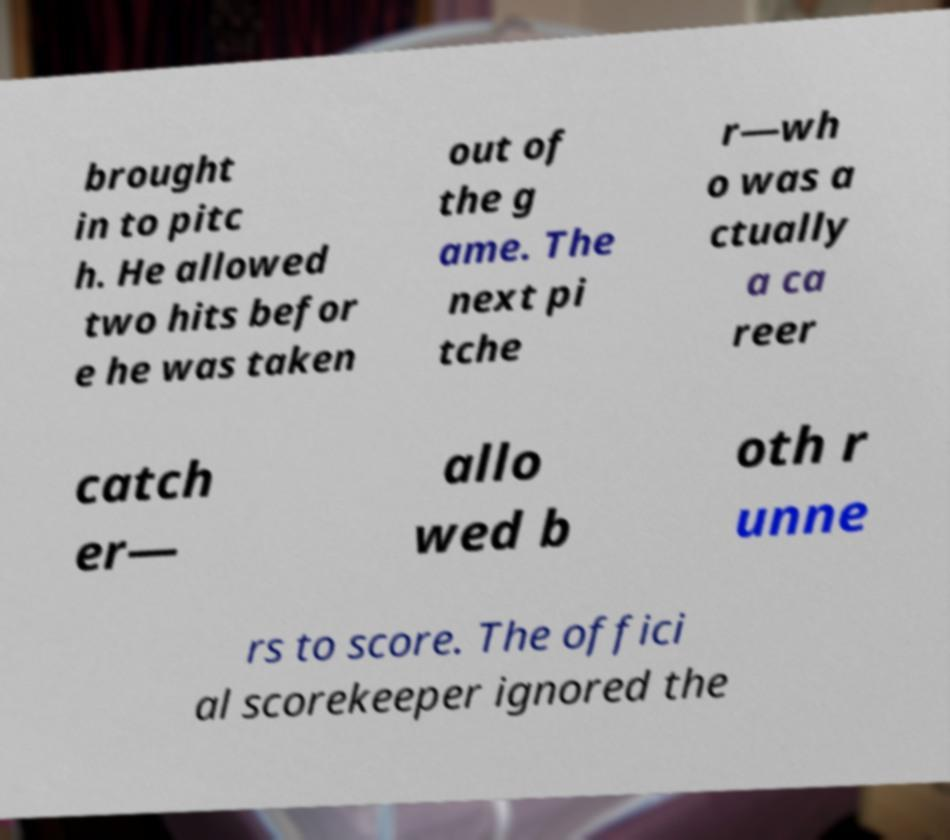Please read and relay the text visible in this image. What does it say? brought in to pitc h. He allowed two hits befor e he was taken out of the g ame. The next pi tche r—wh o was a ctually a ca reer catch er— allo wed b oth r unne rs to score. The offici al scorekeeper ignored the 